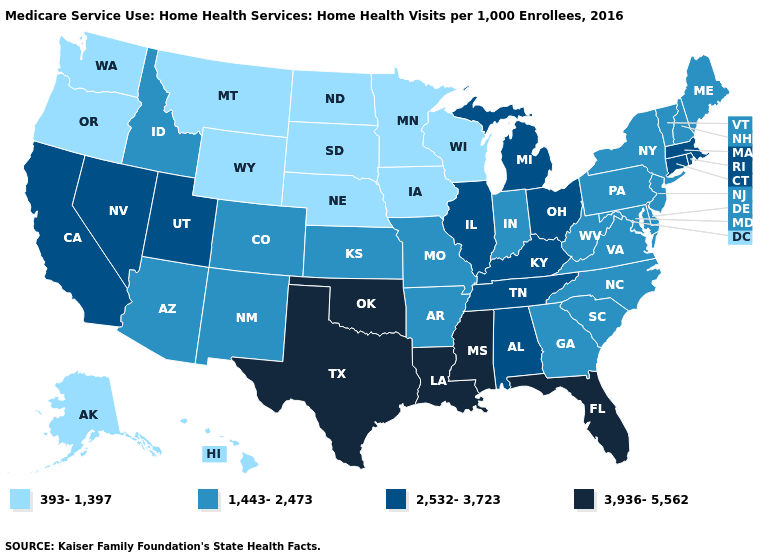What is the lowest value in the USA?
Concise answer only. 393-1,397. Name the states that have a value in the range 2,532-3,723?
Short answer required. Alabama, California, Connecticut, Illinois, Kentucky, Massachusetts, Michigan, Nevada, Ohio, Rhode Island, Tennessee, Utah. What is the lowest value in the USA?
Quick response, please. 393-1,397. What is the value of New Mexico?
Concise answer only. 1,443-2,473. Name the states that have a value in the range 393-1,397?
Answer briefly. Alaska, Hawaii, Iowa, Minnesota, Montana, Nebraska, North Dakota, Oregon, South Dakota, Washington, Wisconsin, Wyoming. Does North Carolina have the highest value in the USA?
Keep it brief. No. What is the lowest value in the West?
Give a very brief answer. 393-1,397. Name the states that have a value in the range 1,443-2,473?
Quick response, please. Arizona, Arkansas, Colorado, Delaware, Georgia, Idaho, Indiana, Kansas, Maine, Maryland, Missouri, New Hampshire, New Jersey, New Mexico, New York, North Carolina, Pennsylvania, South Carolina, Vermont, Virginia, West Virginia. What is the value of Delaware?
Give a very brief answer. 1,443-2,473. What is the highest value in the USA?
Be succinct. 3,936-5,562. What is the value of Louisiana?
Be succinct. 3,936-5,562. Name the states that have a value in the range 1,443-2,473?
Quick response, please. Arizona, Arkansas, Colorado, Delaware, Georgia, Idaho, Indiana, Kansas, Maine, Maryland, Missouri, New Hampshire, New Jersey, New Mexico, New York, North Carolina, Pennsylvania, South Carolina, Vermont, Virginia, West Virginia. Does Missouri have the same value as Maine?
Keep it brief. Yes. Name the states that have a value in the range 393-1,397?
Short answer required. Alaska, Hawaii, Iowa, Minnesota, Montana, Nebraska, North Dakota, Oregon, South Dakota, Washington, Wisconsin, Wyoming. What is the value of Rhode Island?
Give a very brief answer. 2,532-3,723. 